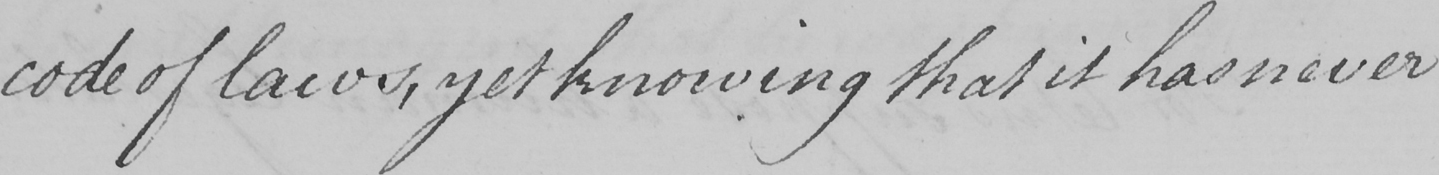Please transcribe the handwritten text in this image. code of laws , yet knowing that it has never 